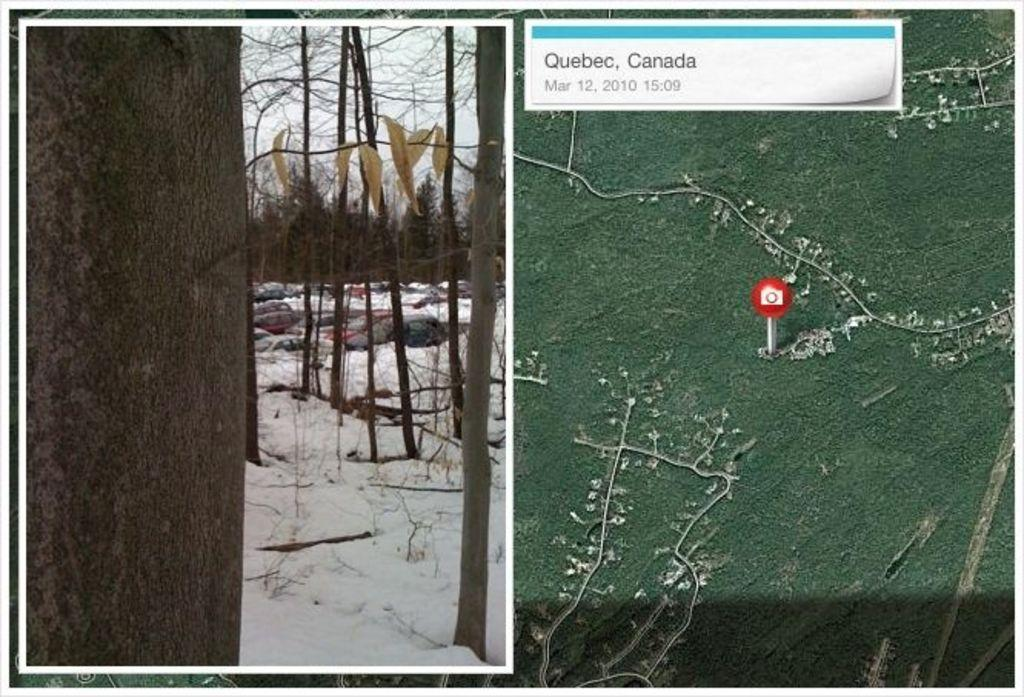What type of picture is in the image? There is a collage picture in the image. What is the weather condition in the image? There is snow visible in the image. What type of natural scenery is present in the image? There are trees in the image. What else can be seen in the sky in the image? The sky is visible in the image. What type of informational tool is present in the image? There is a map in the image. How many slaves are depicted in the image? There are no slaves present in the image. What is the amount of ice in the image? There is no ice present in the image; it is snow that is visible. 